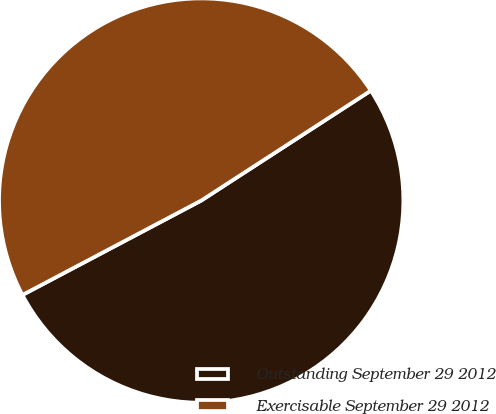Convert chart to OTSL. <chart><loc_0><loc_0><loc_500><loc_500><pie_chart><fcel>Outstanding September 29 2012<fcel>Exercisable September 29 2012<nl><fcel>51.42%<fcel>48.58%<nl></chart> 